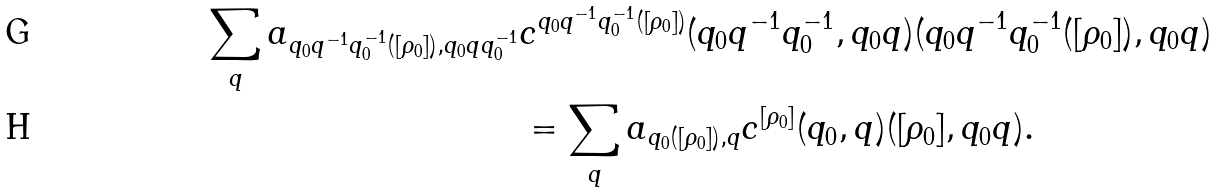<formula> <loc_0><loc_0><loc_500><loc_500>\sum _ { q } a _ { q _ { 0 } q ^ { - 1 } q _ { 0 } ^ { - 1 } ( [ \rho _ { 0 } ] ) , q _ { 0 } q q _ { 0 } ^ { - 1 } } & c ^ { q _ { 0 } q ^ { - 1 } q _ { 0 } ^ { - 1 } ( [ \rho _ { 0 } ] ) } ( q _ { 0 } q ^ { - 1 } q _ { 0 } ^ { - 1 } , q _ { 0 } q ) ( q _ { 0 } q ^ { - 1 } q _ { 0 } ^ { - 1 } ( [ \rho _ { 0 } ] ) , q _ { 0 } q ) \\ & = \sum _ { q } a _ { q _ { 0 } ( [ \rho _ { 0 } ] ) , q } c ^ { [ \rho _ { 0 } ] } ( q _ { 0 } , q ) ( [ \rho _ { 0 } ] , q _ { 0 } q ) .</formula> 